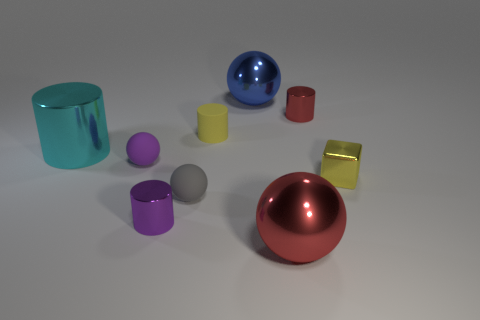Subtract all matte cylinders. How many cylinders are left? 3 Subtract all blocks. How many objects are left? 8 Subtract 1 cubes. How many cubes are left? 0 Subtract all green cylinders. How many blue spheres are left? 1 Subtract all large things. Subtract all tiny metallic cubes. How many objects are left? 5 Add 7 tiny yellow blocks. How many tiny yellow blocks are left? 8 Add 5 purple rubber things. How many purple rubber things exist? 6 Add 1 blue things. How many objects exist? 10 Subtract all gray balls. How many balls are left? 3 Subtract 0 brown spheres. How many objects are left? 9 